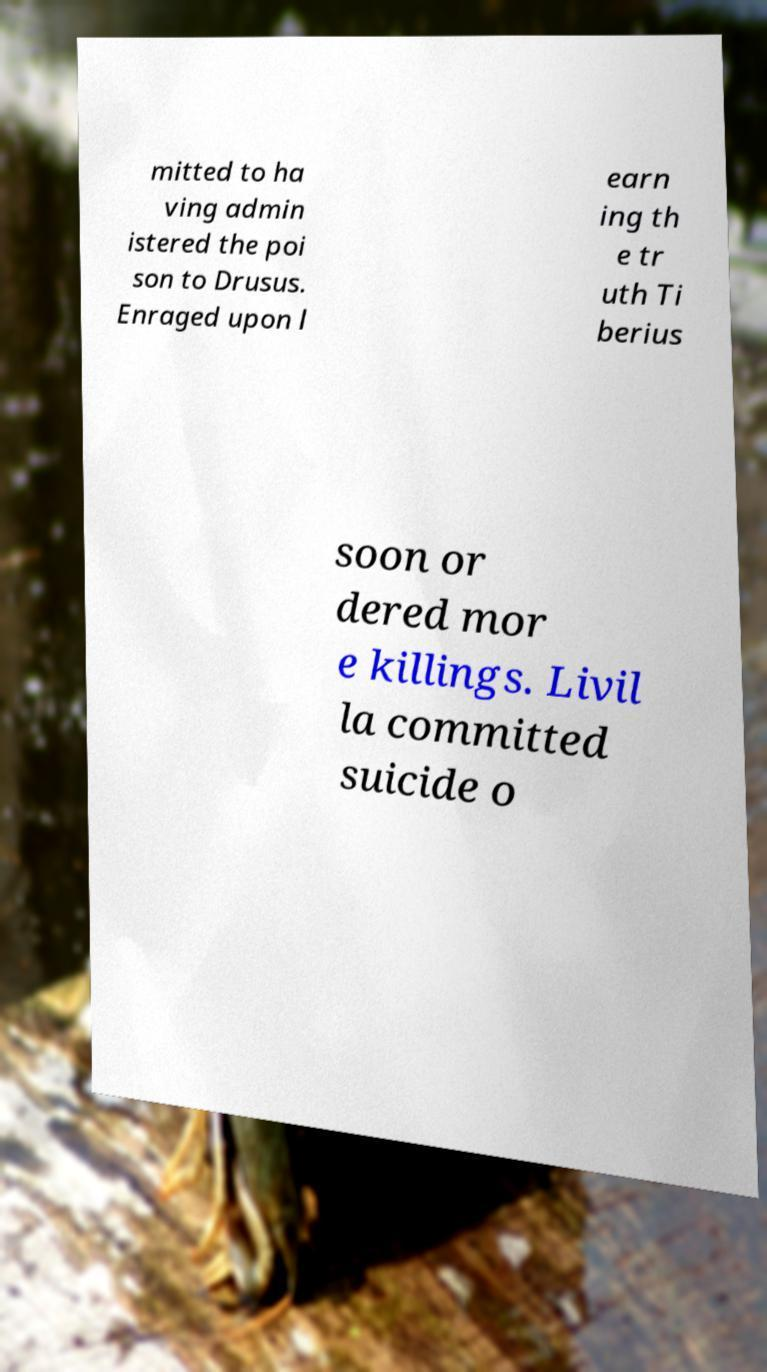Could you extract and type out the text from this image? mitted to ha ving admin istered the poi son to Drusus. Enraged upon l earn ing th e tr uth Ti berius soon or dered mor e killings. Livil la committed suicide o 